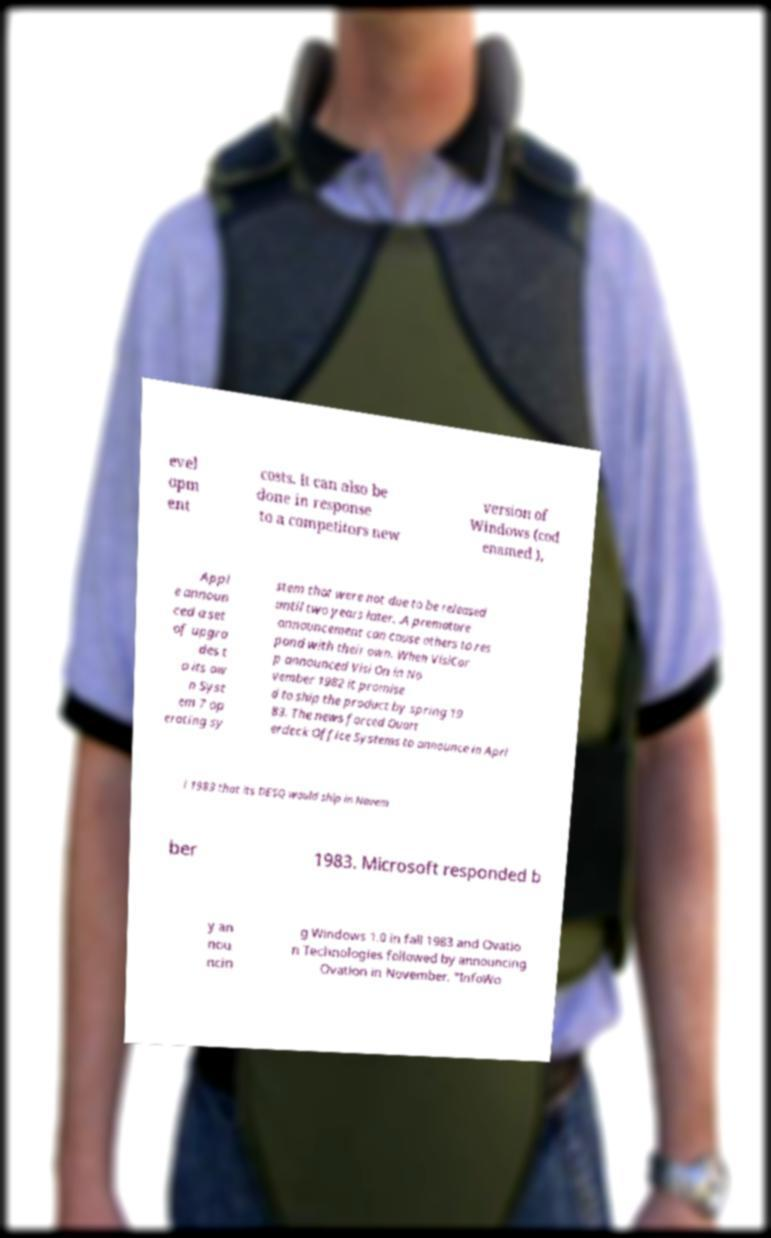Could you assist in decoding the text presented in this image and type it out clearly? evel opm ent costs. It can also be done in response to a competitors new version of Windows (cod enamed ), Appl e announ ced a set of upgra des t o its ow n Syst em 7 op erating sy stem that were not due to be released until two years later. .A premature announcement can cause others to res pond with their own. When VisiCor p announced Visi On in No vember 1982 it promise d to ship the product by spring 19 83. The news forced Quart erdeck Office Systems to announce in Apri l 1983 that its DESQ would ship in Novem ber 1983. Microsoft responded b y an nou ncin g Windows 1.0 in fall 1983 and Ovatio n Technologies followed by announcing Ovation in November. "InfoWo 